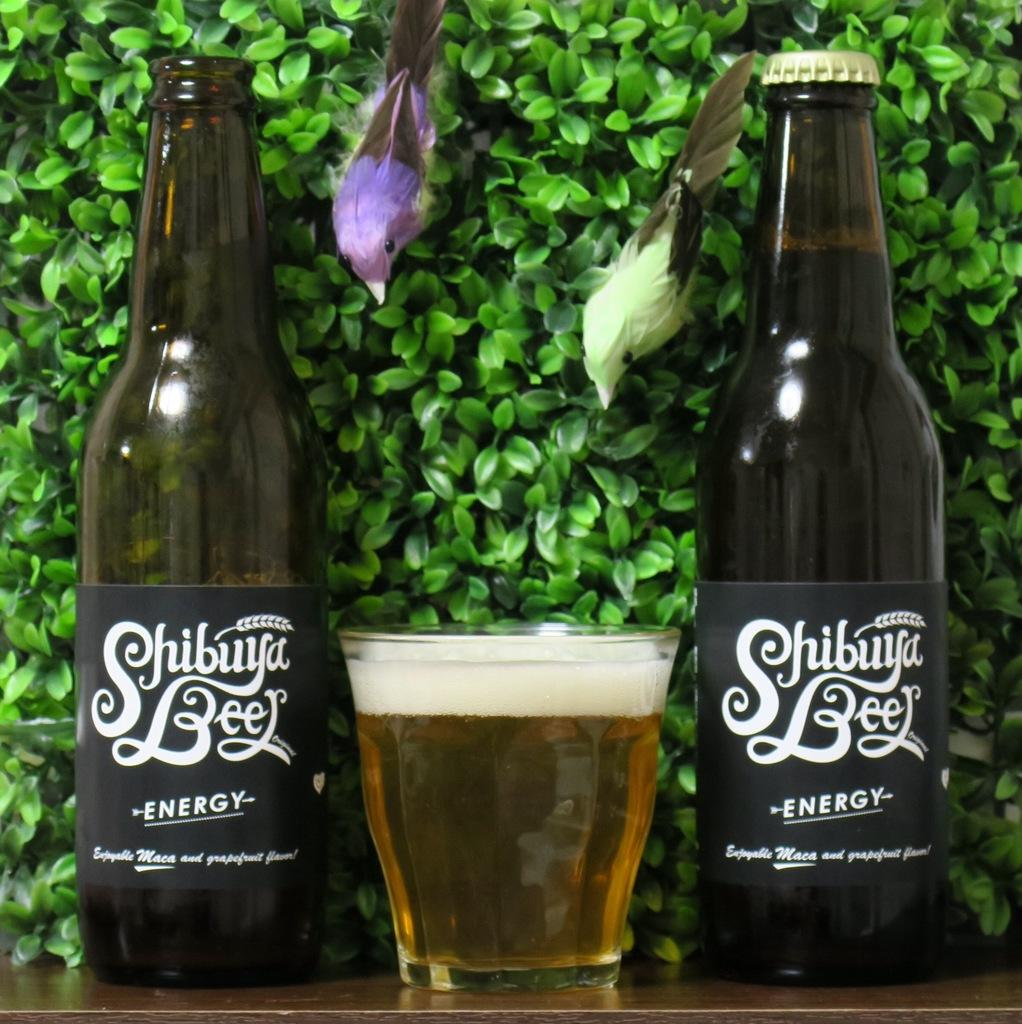<image>
Write a terse but informative summary of the picture. Two bottles of Shibuya beer flank a glass full of beer. 